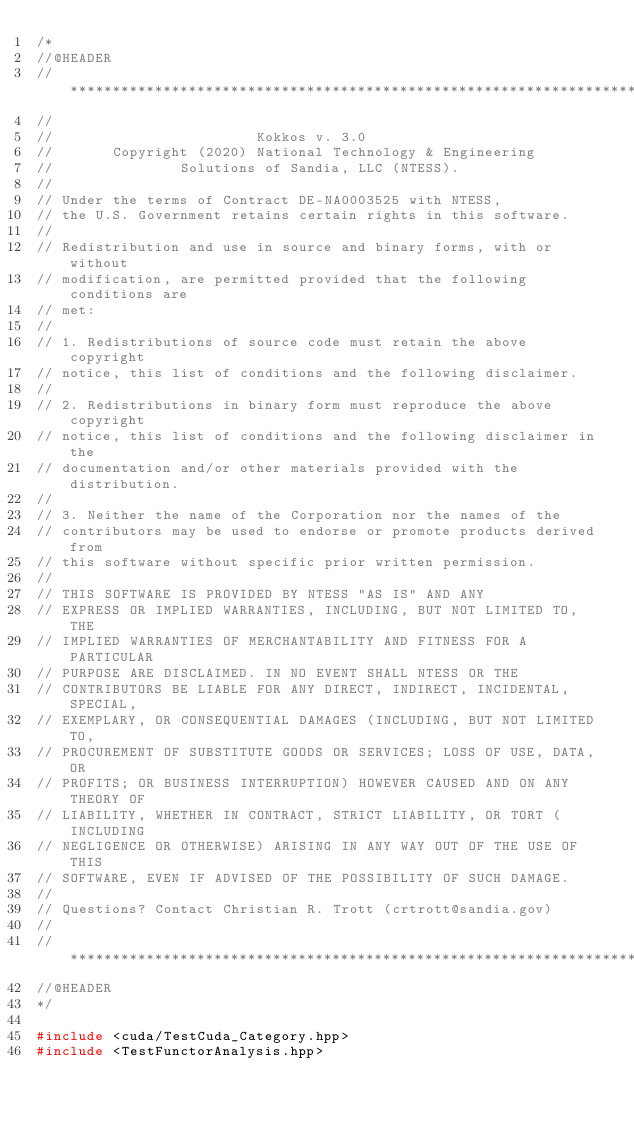Convert code to text. <code><loc_0><loc_0><loc_500><loc_500><_C++_>/*
//@HEADER
// ************************************************************************
//
//                        Kokkos v. 3.0
//       Copyright (2020) National Technology & Engineering
//               Solutions of Sandia, LLC (NTESS).
//
// Under the terms of Contract DE-NA0003525 with NTESS,
// the U.S. Government retains certain rights in this software.
//
// Redistribution and use in source and binary forms, with or without
// modification, are permitted provided that the following conditions are
// met:
//
// 1. Redistributions of source code must retain the above copyright
// notice, this list of conditions and the following disclaimer.
//
// 2. Redistributions in binary form must reproduce the above copyright
// notice, this list of conditions and the following disclaimer in the
// documentation and/or other materials provided with the distribution.
//
// 3. Neither the name of the Corporation nor the names of the
// contributors may be used to endorse or promote products derived from
// this software without specific prior written permission.
//
// THIS SOFTWARE IS PROVIDED BY NTESS "AS IS" AND ANY
// EXPRESS OR IMPLIED WARRANTIES, INCLUDING, BUT NOT LIMITED TO, THE
// IMPLIED WARRANTIES OF MERCHANTABILITY AND FITNESS FOR A PARTICULAR
// PURPOSE ARE DISCLAIMED. IN NO EVENT SHALL NTESS OR THE
// CONTRIBUTORS BE LIABLE FOR ANY DIRECT, INDIRECT, INCIDENTAL, SPECIAL,
// EXEMPLARY, OR CONSEQUENTIAL DAMAGES (INCLUDING, BUT NOT LIMITED TO,
// PROCUREMENT OF SUBSTITUTE GOODS OR SERVICES; LOSS OF USE, DATA, OR
// PROFITS; OR BUSINESS INTERRUPTION) HOWEVER CAUSED AND ON ANY THEORY OF
// LIABILITY, WHETHER IN CONTRACT, STRICT LIABILITY, OR TORT (INCLUDING
// NEGLIGENCE OR OTHERWISE) ARISING IN ANY WAY OUT OF THE USE OF THIS
// SOFTWARE, EVEN IF ADVISED OF THE POSSIBILITY OF SUCH DAMAGE.
//
// Questions? Contact Christian R. Trott (crtrott@sandia.gov)
//
// ************************************************************************
//@HEADER
*/

#include <cuda/TestCuda_Category.hpp>
#include <TestFunctorAnalysis.hpp>
</code> 